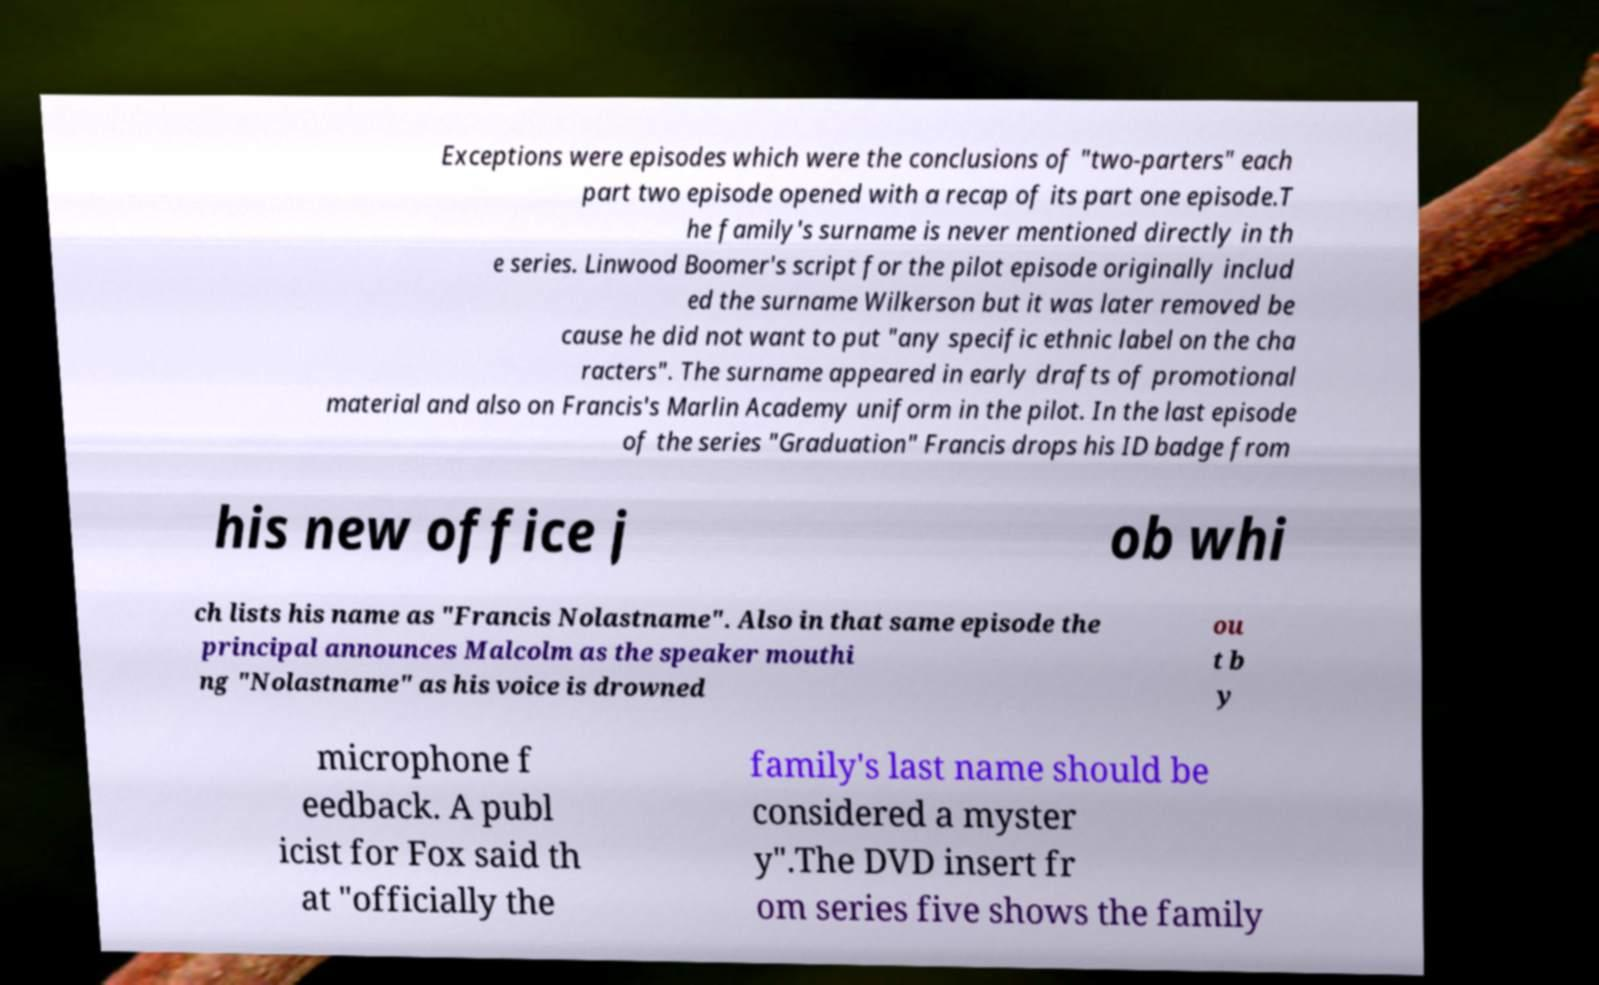Please read and relay the text visible in this image. What does it say? Exceptions were episodes which were the conclusions of "two-parters" each part two episode opened with a recap of its part one episode.T he family's surname is never mentioned directly in th e series. Linwood Boomer's script for the pilot episode originally includ ed the surname Wilkerson but it was later removed be cause he did not want to put "any specific ethnic label on the cha racters". The surname appeared in early drafts of promotional material and also on Francis's Marlin Academy uniform in the pilot. In the last episode of the series "Graduation" Francis drops his ID badge from his new office j ob whi ch lists his name as "Francis Nolastname". Also in that same episode the principal announces Malcolm as the speaker mouthi ng "Nolastname" as his voice is drowned ou t b y microphone f eedback. A publ icist for Fox said th at "officially the family's last name should be considered a myster y".The DVD insert fr om series five shows the family 